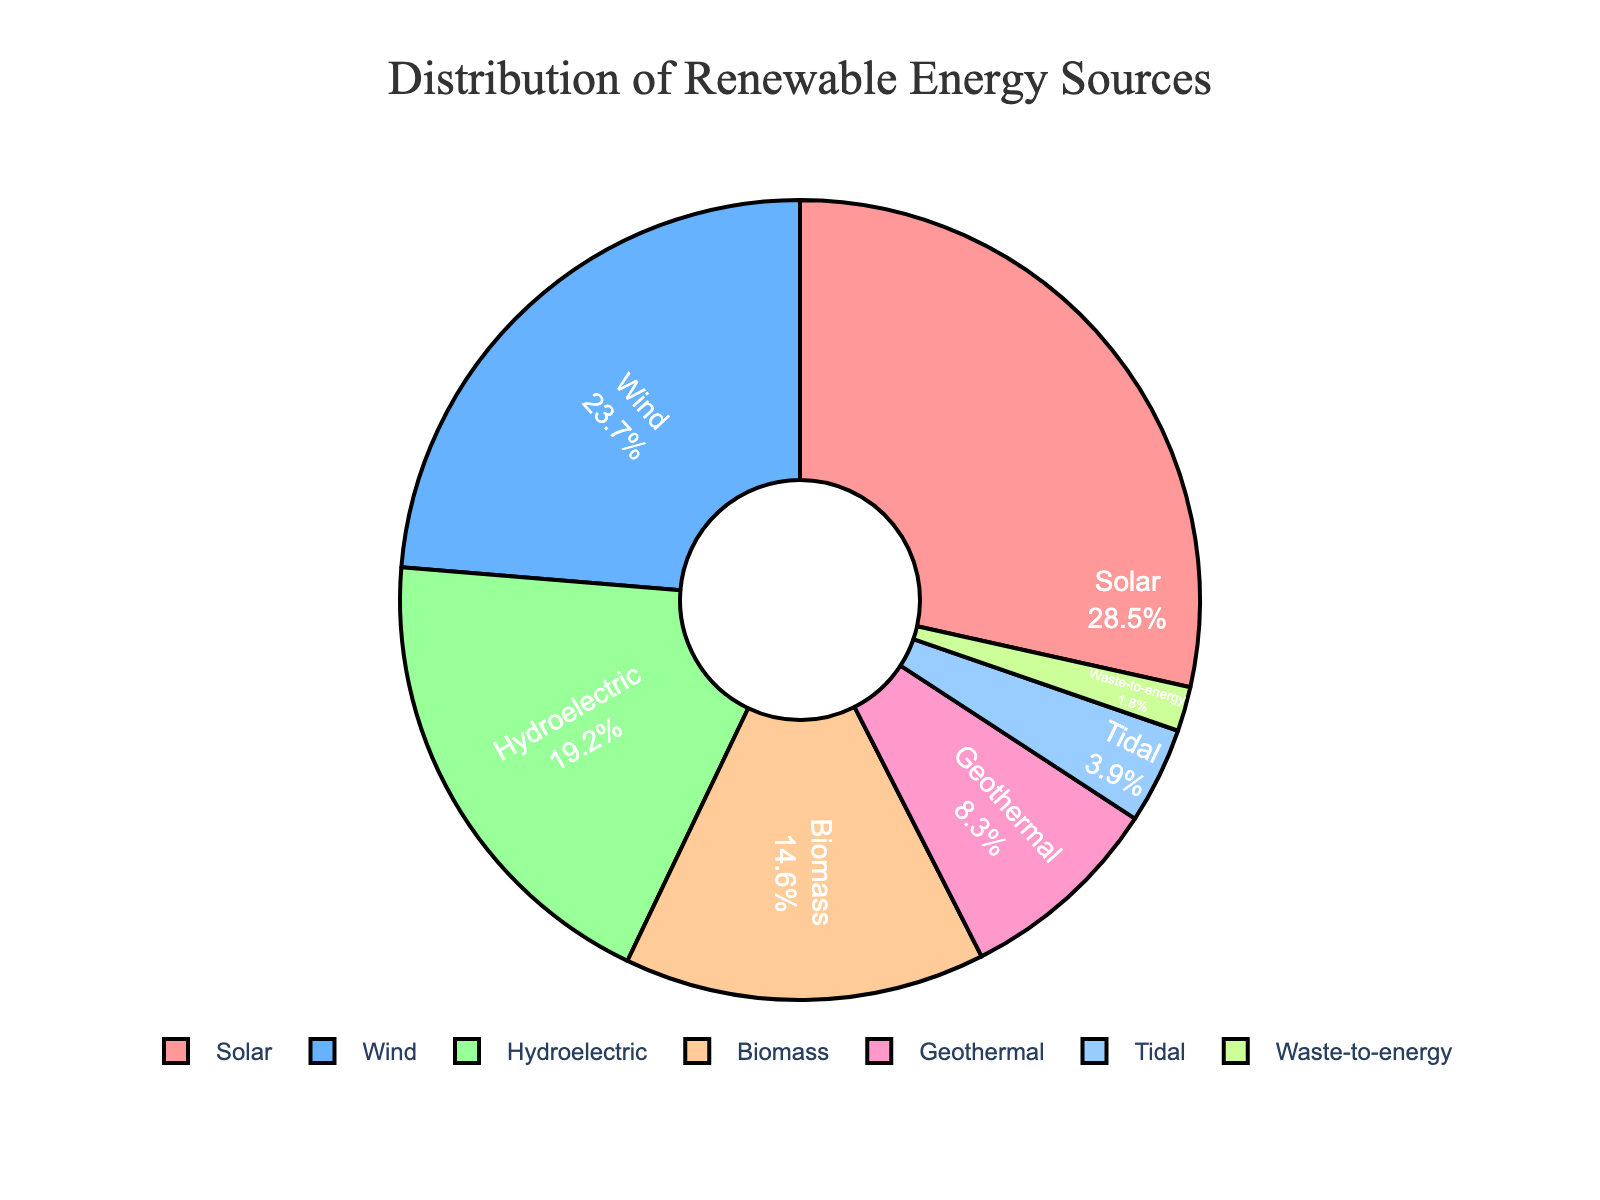What is the percentage of energy generated by Solar and Wind combined? Identify the percentage values for Solar (28.5%) and Wind (23.7%) from the figure, then sum these values: 28.5 + 23.7 = 52.2
Answer: 52.2 Which energy source has the smallest share in the distribution? Examine the wedges in the pie chart and identify the one with the smallest percentage. Waste-to-energy is represented with the smallest slice at 1.8%.
Answer: Waste-to-energy How does the percentage of Hydroelectric compare to Biomass? From the figure, Hydroelectric has 19.2%, and Biomass has 14.6%. Hydroelectric is greater than Biomass by 19.2 - 14.6.
Answer: Hydroelectric is greater by 4.6 What is the second least common renewable energy source? Identify the slices by descending order of percentage share. Tidal energy appears second to last with 3.9%.
Answer: Tidal What percentage of the total is not Solar energy? Solar energy represents 28.5%. Subtract this from 100% to find the remaining percentage: 100 - 28.5 = 71.5.
Answer: 71.5 Which color represents Biomass energy in the pie chart? Biomass is associated with 14.6%, which is the fourth slice. Referring to the fourth color in the legend or slice order, it is orange (or the specified color in the figure).
Answer: Orange Is the combined share of Tidal and Waste-to-energy less than Geothermal? Tidal (3.9%) and Waste-to-energy (1.8%) sum to 3.9 + 1.8 = 5.7%. Geothermal is 8.3%. 5.7% is less than 8.3%.
Answer: Yes What is the difference between the shares of Solar and Geothermal energy? Solar is 28.5% and Geothermal is 8.3%. Subtract the smaller percentage from the larger: 28.5 - 8.3.
Answer: 20.2 Which renewable energy source has a larger share: Wind or Hydroelectric? Compare the percentages of Wind (23.7%) and Hydroelectric (19.2%) directly from the figure. Wind has a larger share.
Answer: Wind If Biomass and Tidal percentages were combined into a single category, what would be its share? Sum Biomass (14.6%) and Tidal (3.9%): 14.6 + 3.9 = 18.5.
Answer: 18.5 